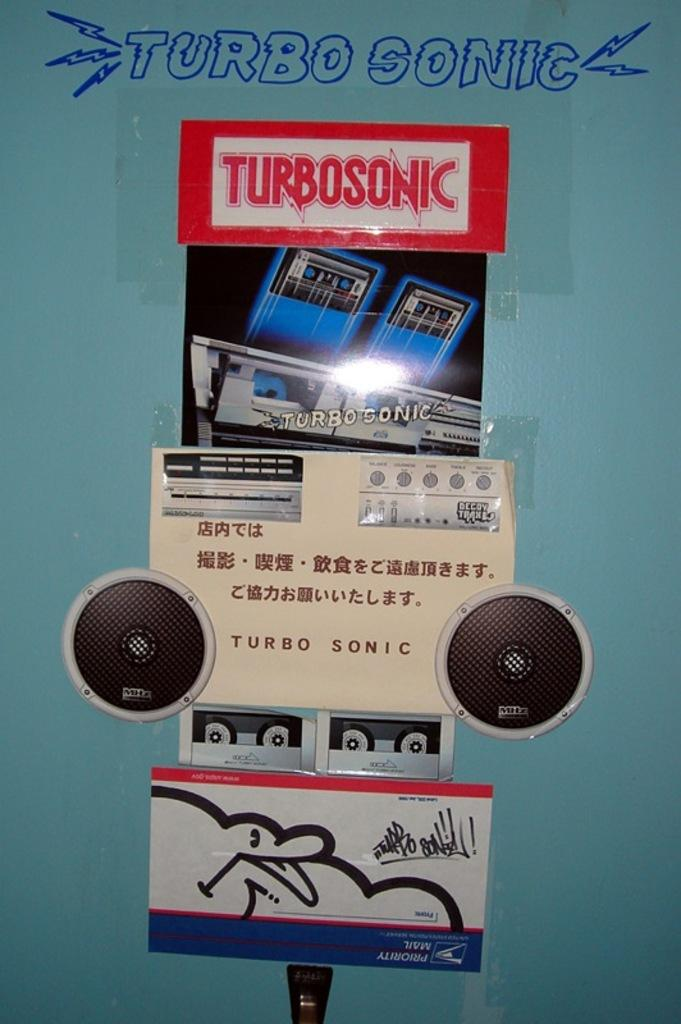<image>
Offer a succinct explanation of the picture presented. Someone has written Turbo Sonic on the wall in blue ink. 